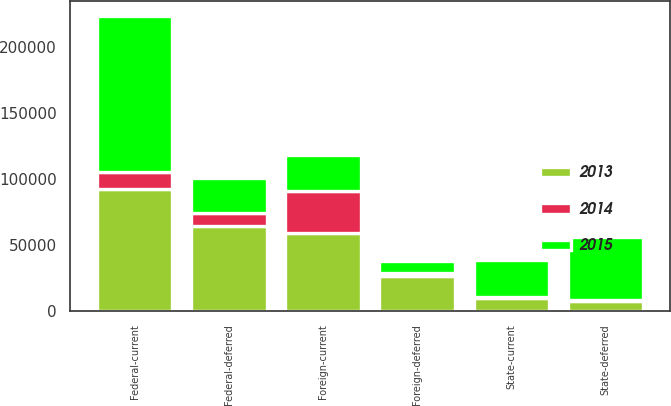Convert chart. <chart><loc_0><loc_0><loc_500><loc_500><stacked_bar_chart><ecel><fcel>Federal-current<fcel>Federal-deferred<fcel>State-current<fcel>State-deferred<fcel>Foreign-current<fcel>Foreign-deferred<nl><fcel>2013<fcel>92237<fcel>64441<fcel>10152<fcel>8056<fcel>59170<fcel>26935<nl><fcel>2015<fcel>118314<fcel>26935<fcel>28034<fcel>47814<fcel>27167<fcel>8844<nl><fcel>2014<fcel>13083<fcel>9579<fcel>522<fcel>158<fcel>31581<fcel>1948<nl></chart> 